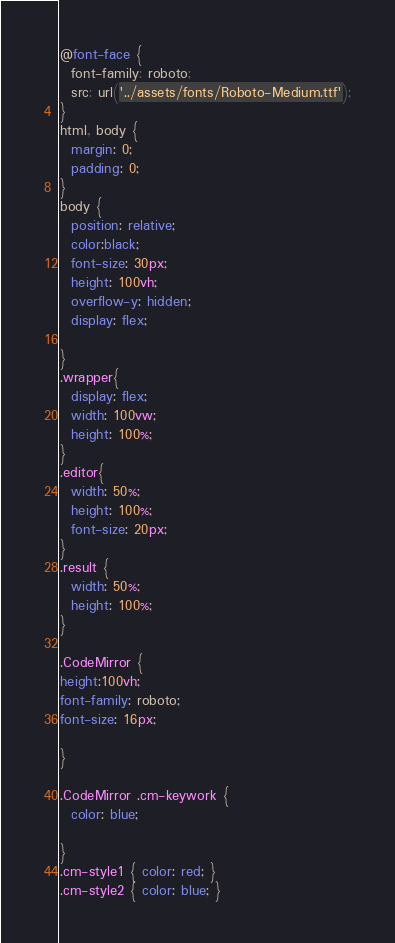<code> <loc_0><loc_0><loc_500><loc_500><_CSS_>@font-face {
  font-family: roboto;
  src: url('../assets/fonts/Roboto-Medium.ttf');
}
html, body {
  margin: 0;
  padding: 0;
}
body {
  position: relative;
  color:black;
  font-size: 30px;
  height: 100vh;
  overflow-y: hidden;
  display: flex;
  
}
.wrapper{
  display: flex;
  width: 100vw;
  height: 100%;
}
.editor{
  width: 50%;
  height: 100%;
  font-size: 20px;
}
.result {
  width: 50%;
  height: 100%;
}

.CodeMirror {
height:100vh;
font-family: roboto;
font-size: 16px;

}

.CodeMirror .cm-keywork {
  color: blue;

}
.cm-style1 { color: red; }
.cm-style2 { color: blue; }</code> 